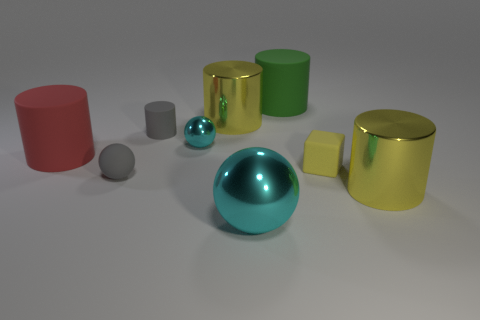Subtract all gray cylinders. How many cylinders are left? 4 Subtract all blue cylinders. Subtract all cyan spheres. How many cylinders are left? 5 Add 1 big cyan objects. How many objects exist? 10 Subtract all blocks. How many objects are left? 8 Subtract all big purple objects. Subtract all green cylinders. How many objects are left? 8 Add 3 rubber spheres. How many rubber spheres are left? 4 Add 4 cylinders. How many cylinders exist? 9 Subtract 0 green balls. How many objects are left? 9 